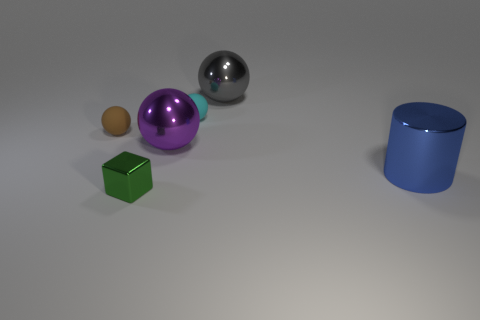Subtract all tiny brown rubber balls. How many balls are left? 3 Add 4 small shiny objects. How many objects exist? 10 Subtract 1 blocks. How many blocks are left? 0 Subtract all cyan balls. How many balls are left? 3 Add 3 cyan matte things. How many cyan matte things are left? 4 Add 4 tiny blue rubber cylinders. How many tiny blue rubber cylinders exist? 4 Subtract 1 cyan spheres. How many objects are left? 5 Subtract all blocks. How many objects are left? 5 Subtract all brown cylinders. Subtract all purple blocks. How many cylinders are left? 1 Subtract all brown cubes. How many cyan spheres are left? 1 